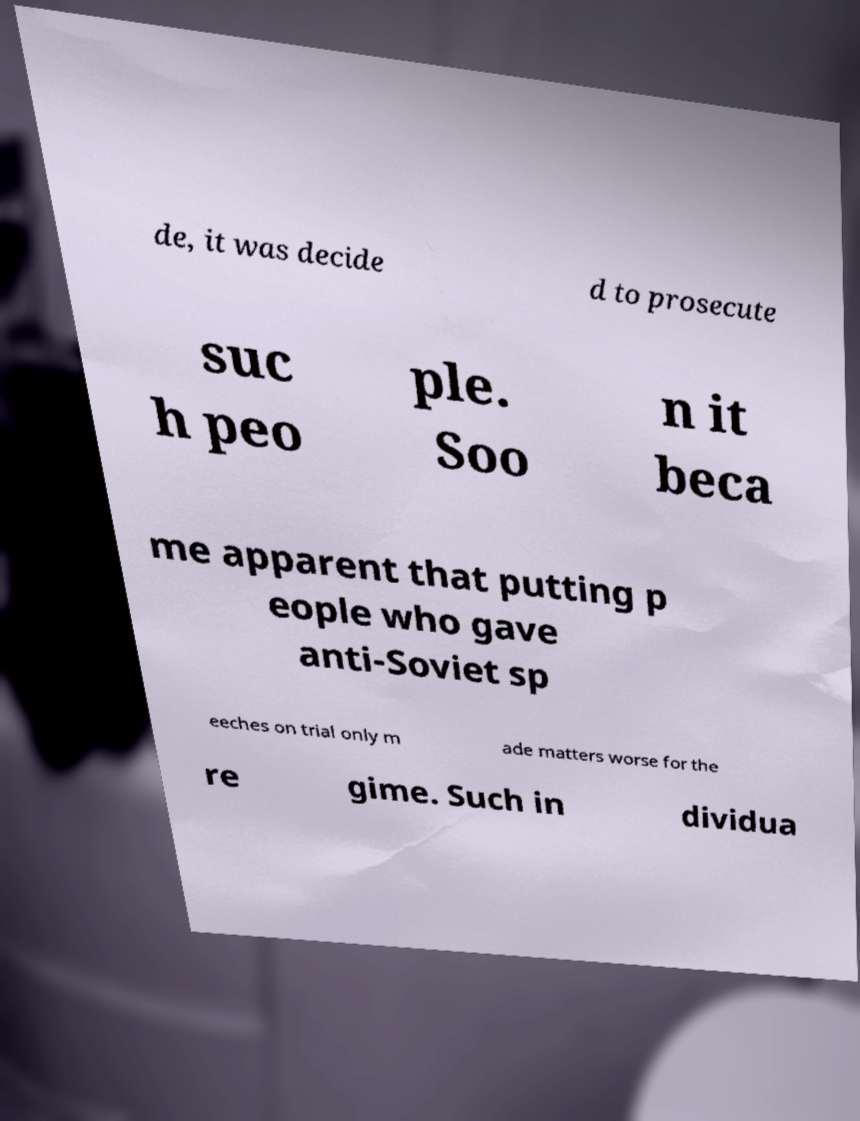Can you accurately transcribe the text from the provided image for me? de, it was decide d to prosecute suc h peo ple. Soo n it beca me apparent that putting p eople who gave anti-Soviet sp eeches on trial only m ade matters worse for the re gime. Such in dividua 